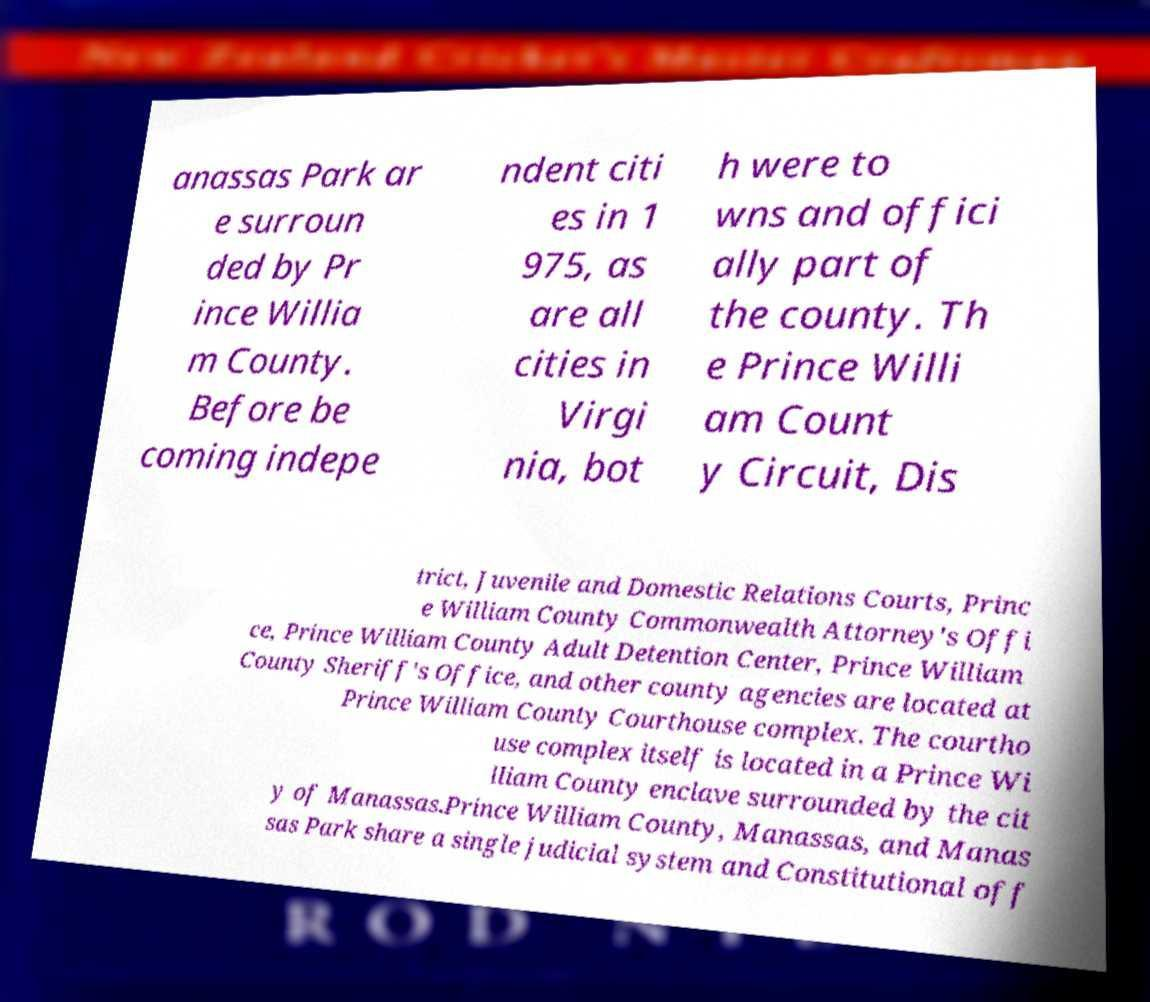Could you assist in decoding the text presented in this image and type it out clearly? anassas Park ar e surroun ded by Pr ince Willia m County. Before be coming indepe ndent citi es in 1 975, as are all cities in Virgi nia, bot h were to wns and offici ally part of the county. Th e Prince Willi am Count y Circuit, Dis trict, Juvenile and Domestic Relations Courts, Princ e William County Commonwealth Attorney's Offi ce, Prince William County Adult Detention Center, Prince William County Sheriff's Office, and other county agencies are located at Prince William County Courthouse complex. The courtho use complex itself is located in a Prince Wi lliam County enclave surrounded by the cit y of Manassas.Prince William County, Manassas, and Manas sas Park share a single judicial system and Constitutional off 